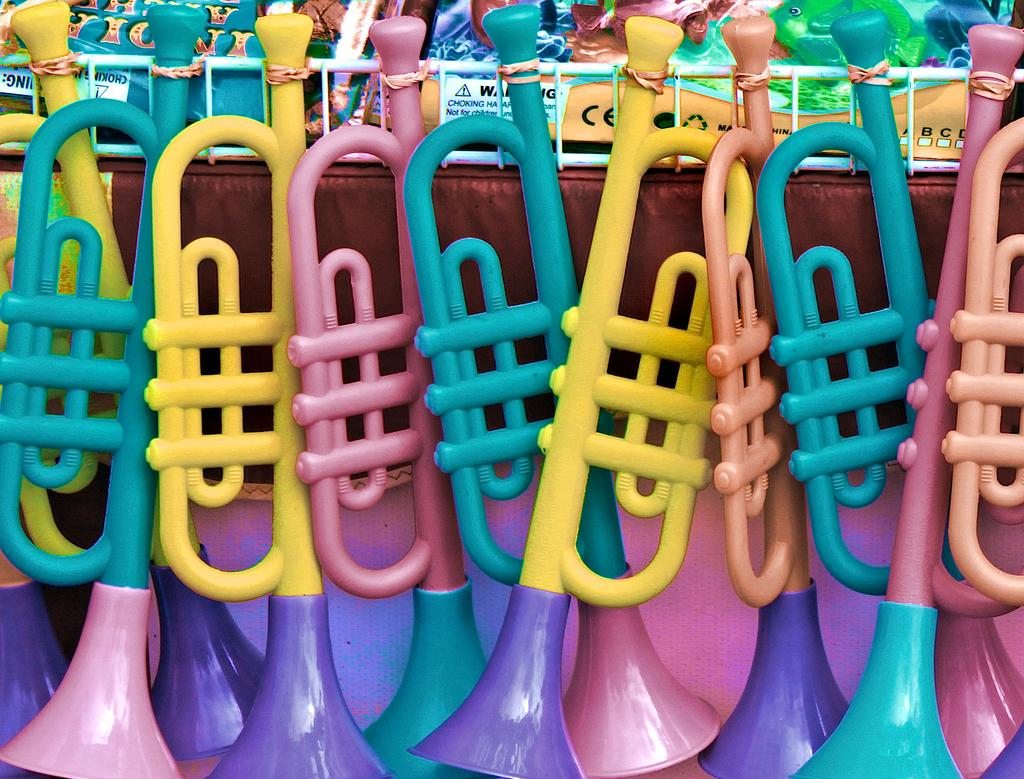What type of objects can be seen in the image? There are toys in the image. How many friends does the toy expert have in the image? There is no toy expert or friends mentioned in the image; it only contains toys. 